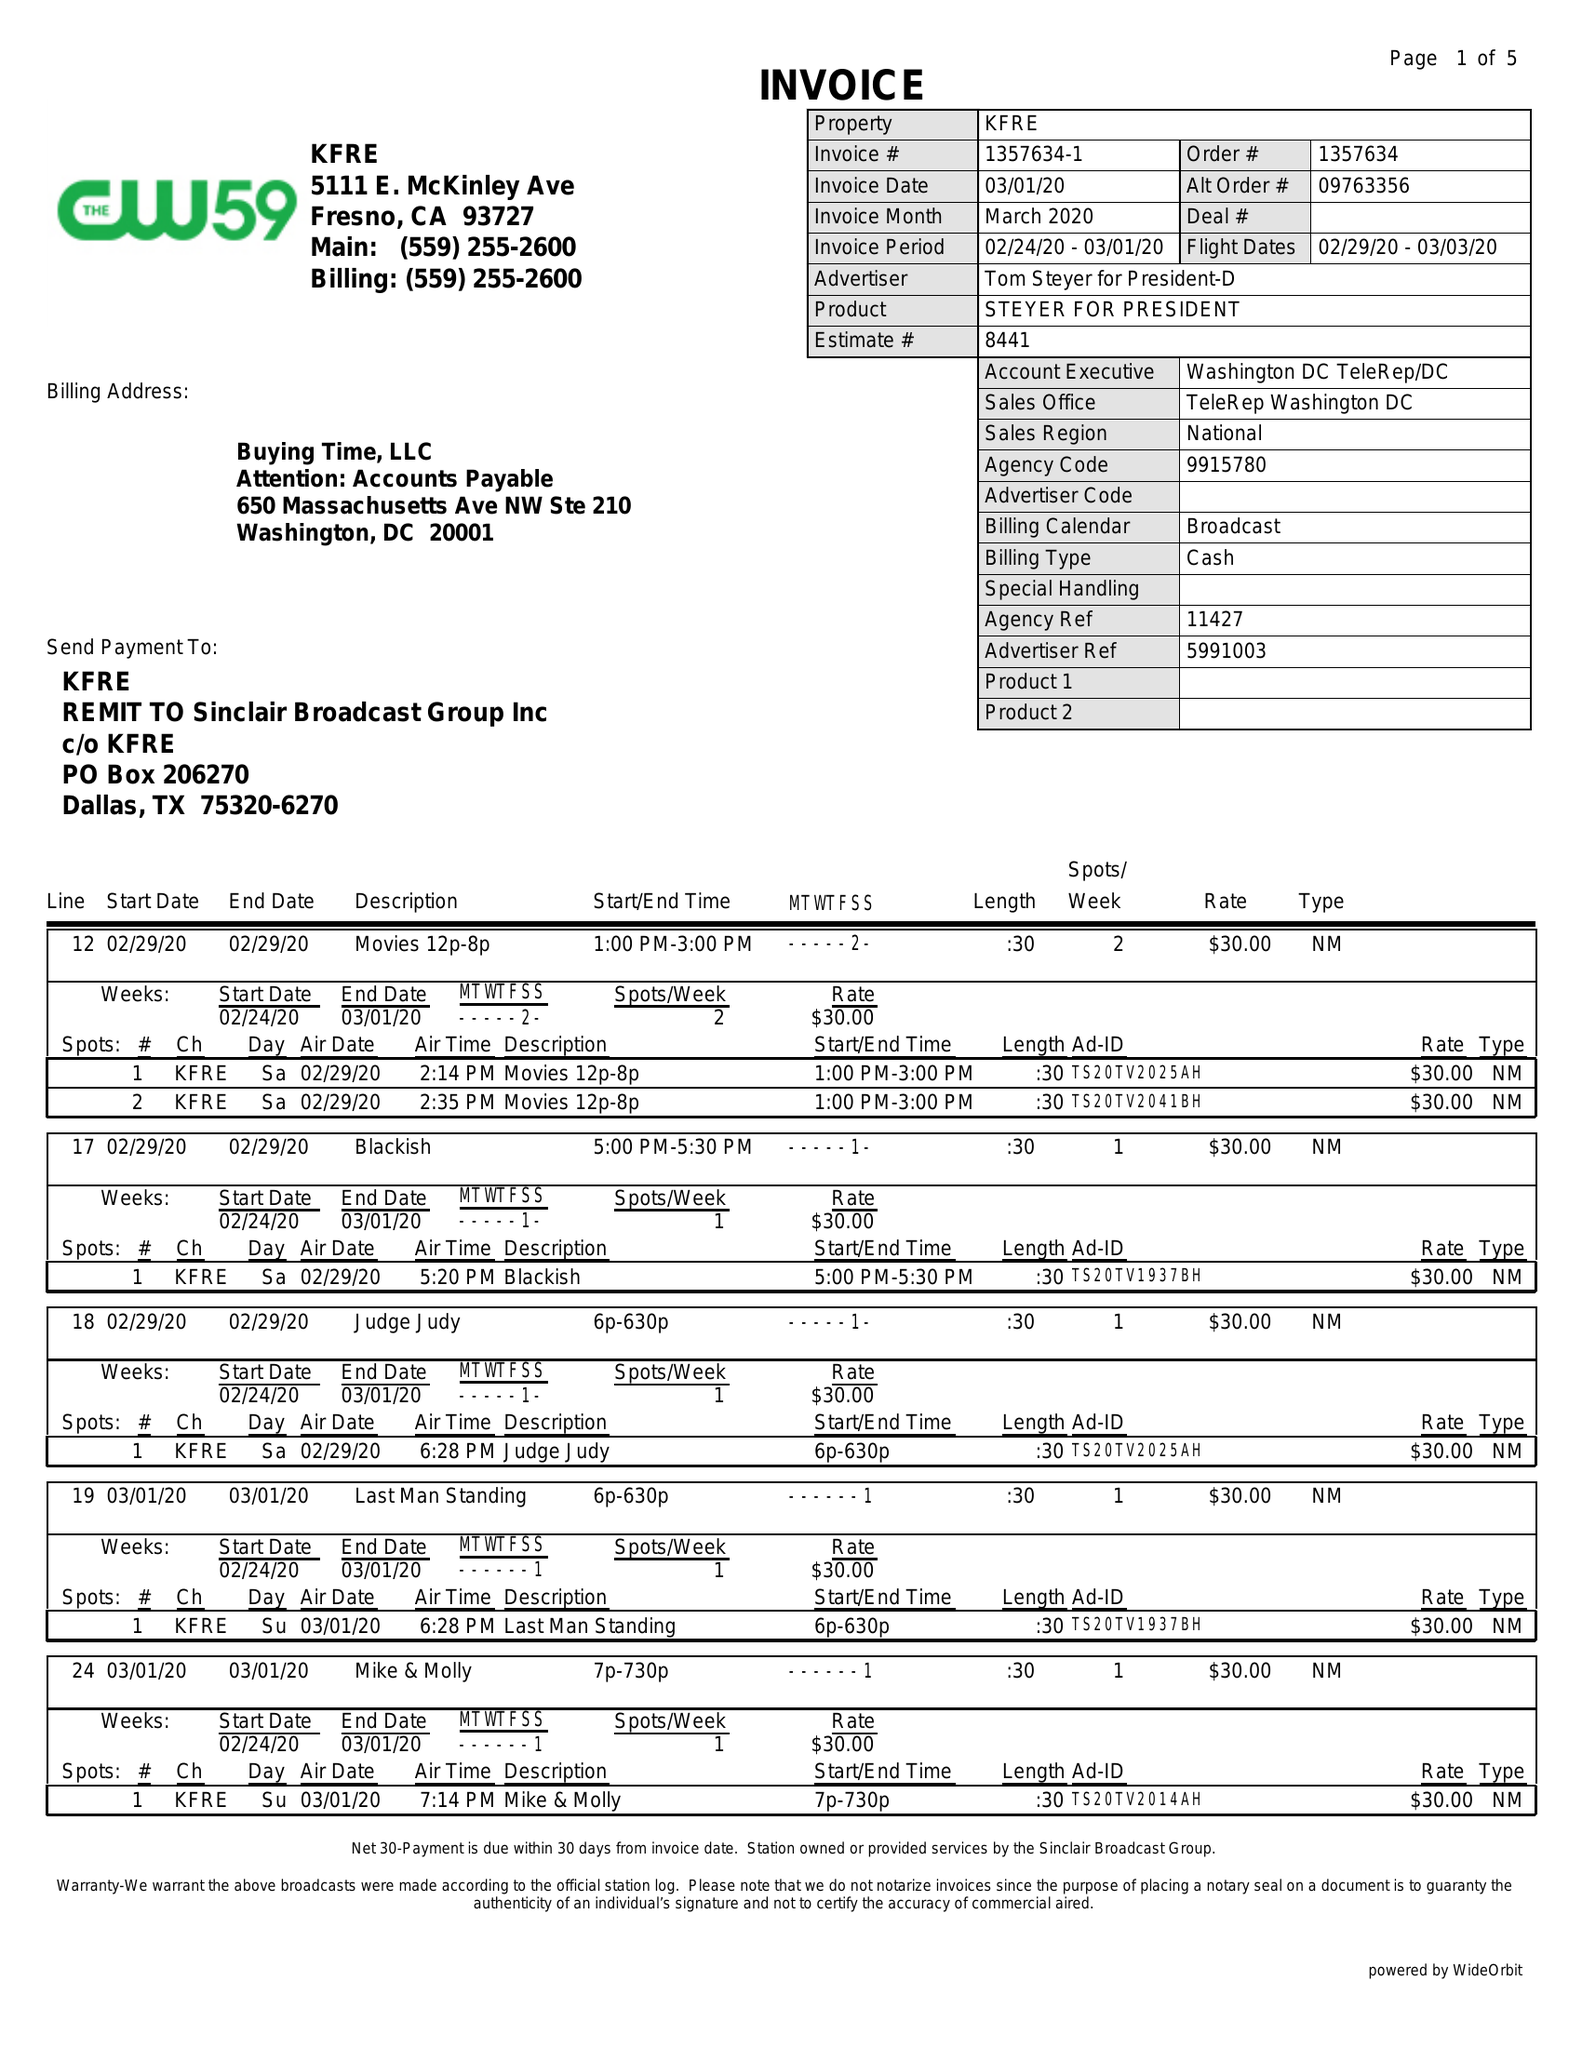What is the value for the gross_amount?
Answer the question using a single word or phrase. 1720.00 